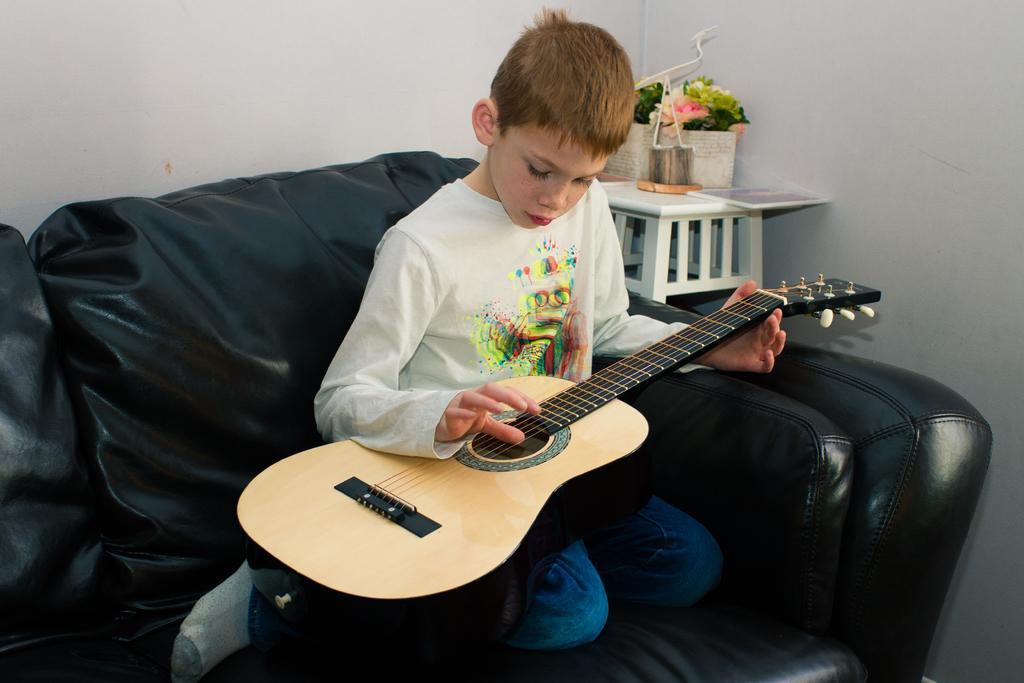How would you summarize this image in a sentence or two? On the background we can see a wall in white colour and a table. On the table we can see flower pots. Here on the black sofa one boy sitting and playing guitar. 